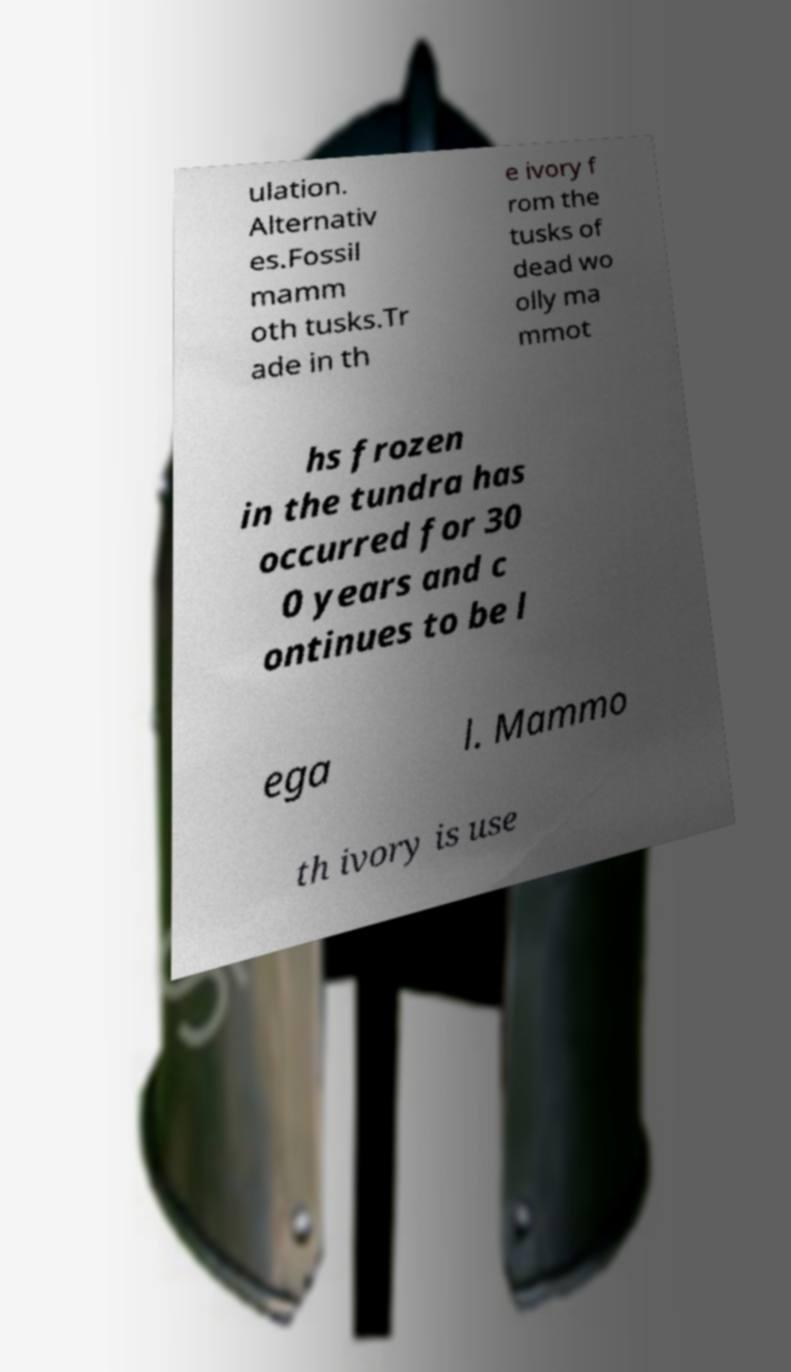Can you read and provide the text displayed in the image?This photo seems to have some interesting text. Can you extract and type it out for me? ulation. Alternativ es.Fossil mamm oth tusks.Tr ade in th e ivory f rom the tusks of dead wo olly ma mmot hs frozen in the tundra has occurred for 30 0 years and c ontinues to be l ega l. Mammo th ivory is use 